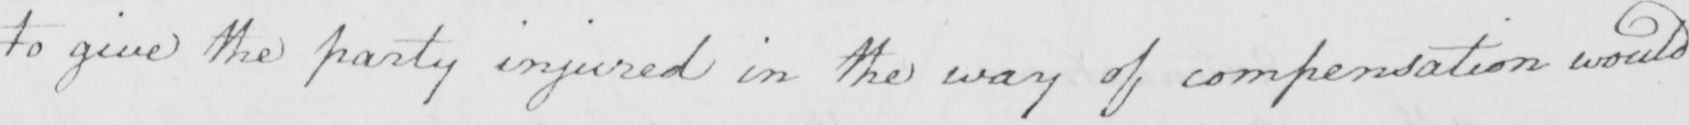Can you tell me what this handwritten text says? to give the party injured in the way of compensation would 